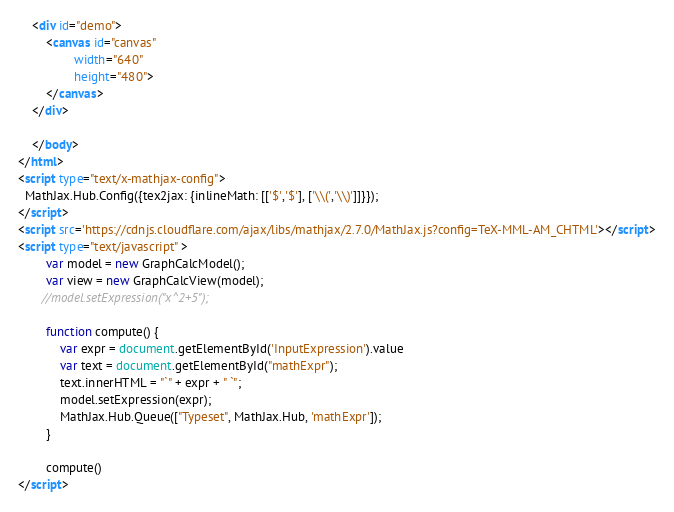<code> <loc_0><loc_0><loc_500><loc_500><_HTML_>    <div id="demo">
        <canvas id="canvas"   
                width="640"
                height="480">
        </canvas>
    </div>

    </body>
</html> 
<script type="text/x-mathjax-config">
  MathJax.Hub.Config({tex2jax: {inlineMath: [['$','$'], ['\\(','\\)']]}});
</script>
<script src='https://cdnjs.cloudflare.com/ajax/libs/mathjax/2.7.0/MathJax.js?config=TeX-MML-AM_CHTML'></script>
<script type="text/javascript" >
        var model = new GraphCalcModel();
        var view = new GraphCalcView(model);
       //model.setExpression("x^2+5");
  
        function compute() {
            var expr = document.getElementById('InputExpression').value   
            var text = document.getElementById("mathExpr");
            text.innerHTML = "`" + expr + " `";
            model.setExpression(expr);     
            MathJax.Hub.Queue(["Typeset", MathJax.Hub, 'mathExpr']);
        }

        compute()
</script>


</code> 